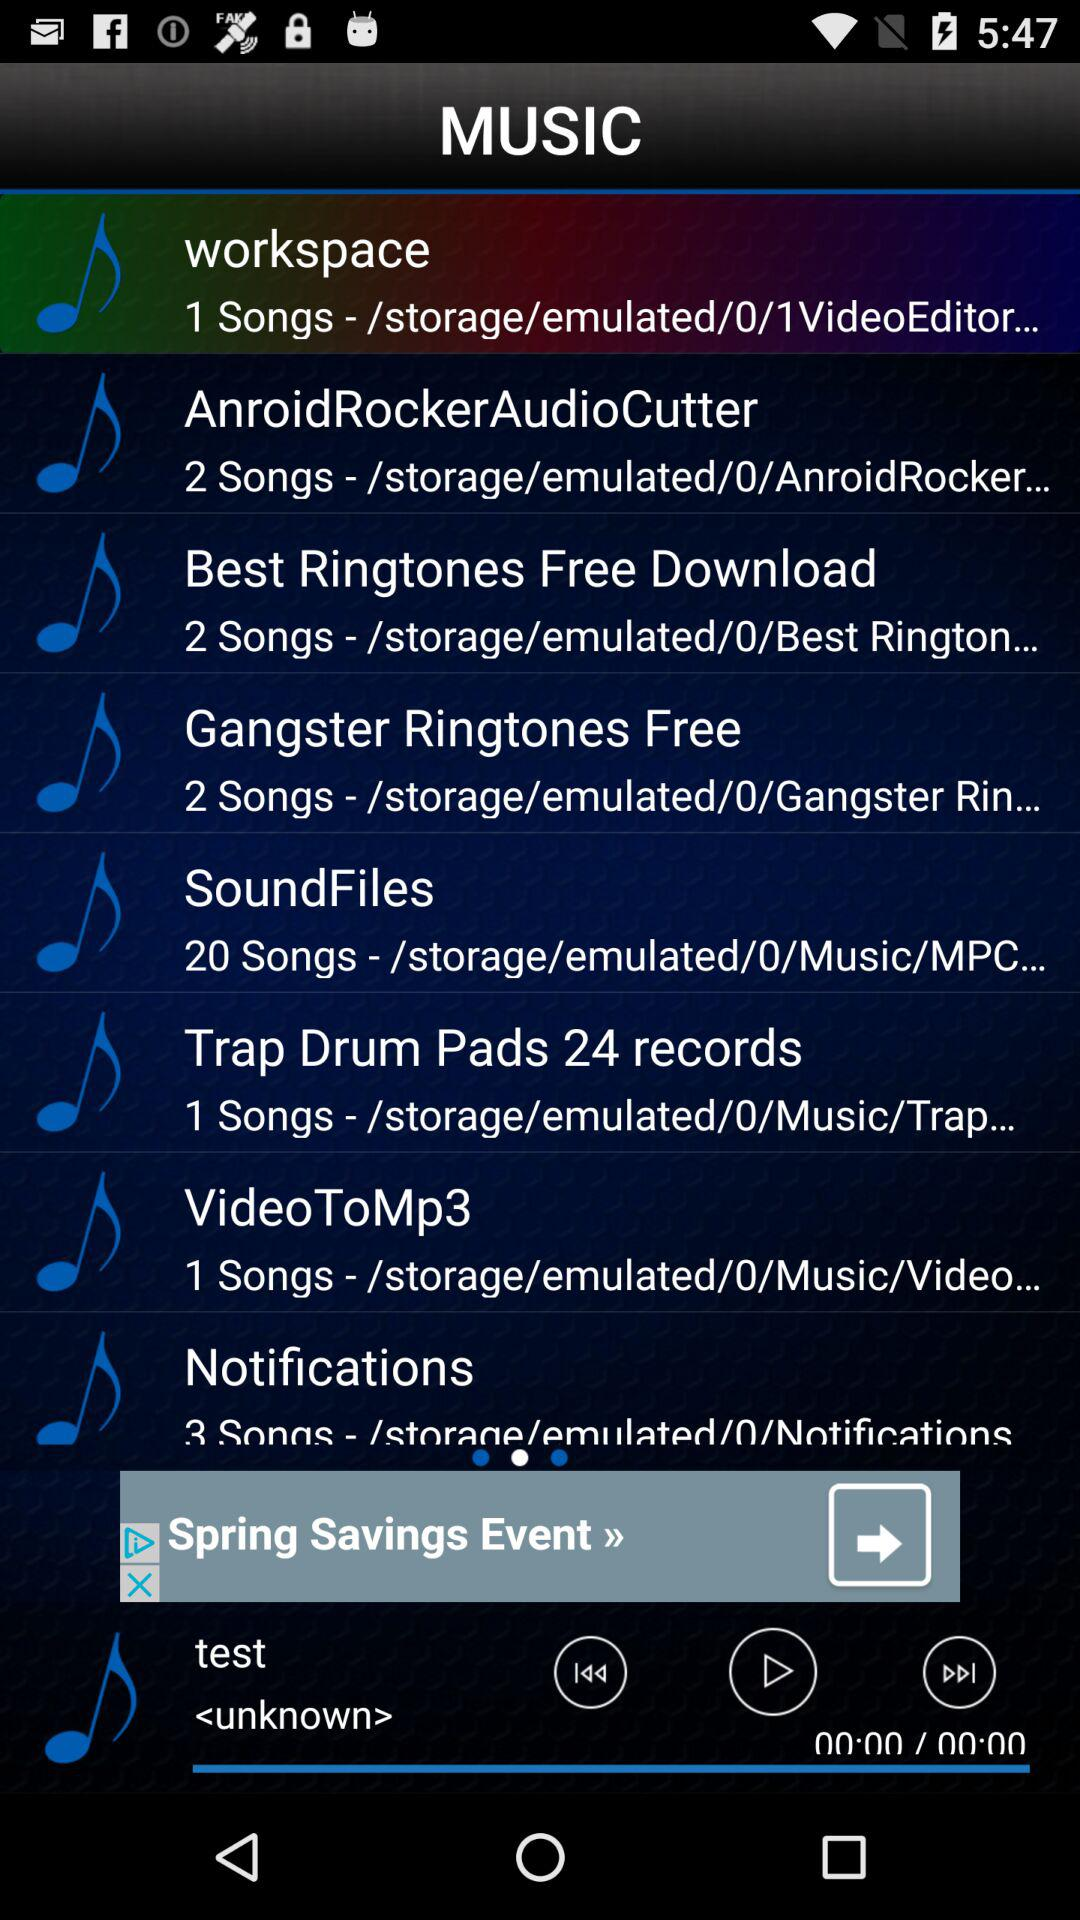How many songs are in the SoundFiles folder?
Answer the question using a single word or phrase. 20 